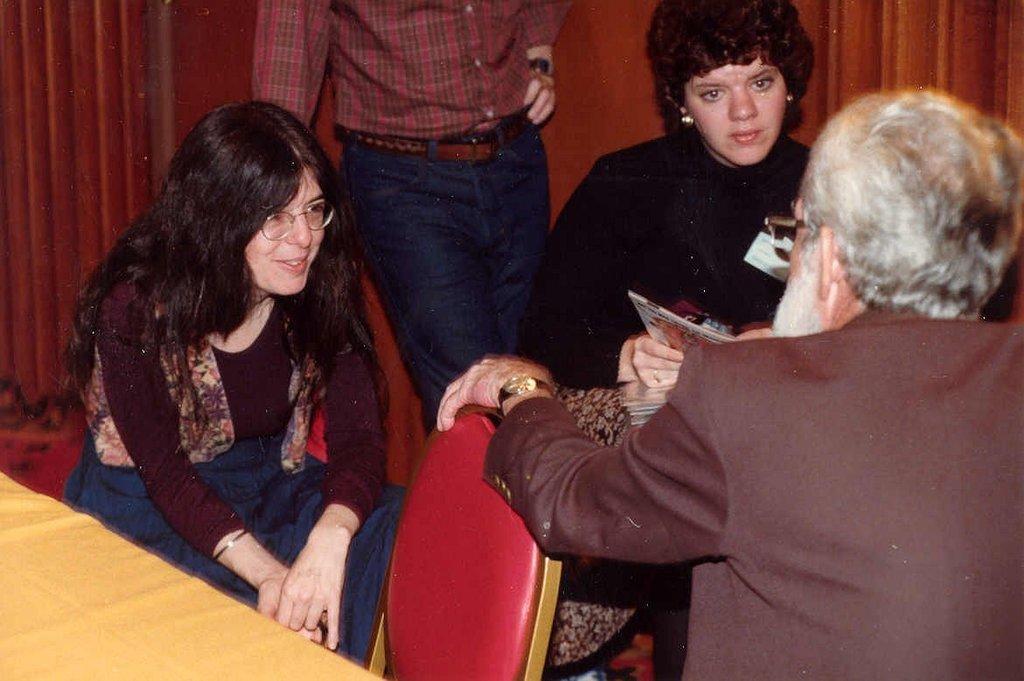How would you summarize this image in a sentence or two? In this image in the center there are three people who are sitting on chairs, and there is one person who is standing. On the left side there is one table, in the background there is a wall. 